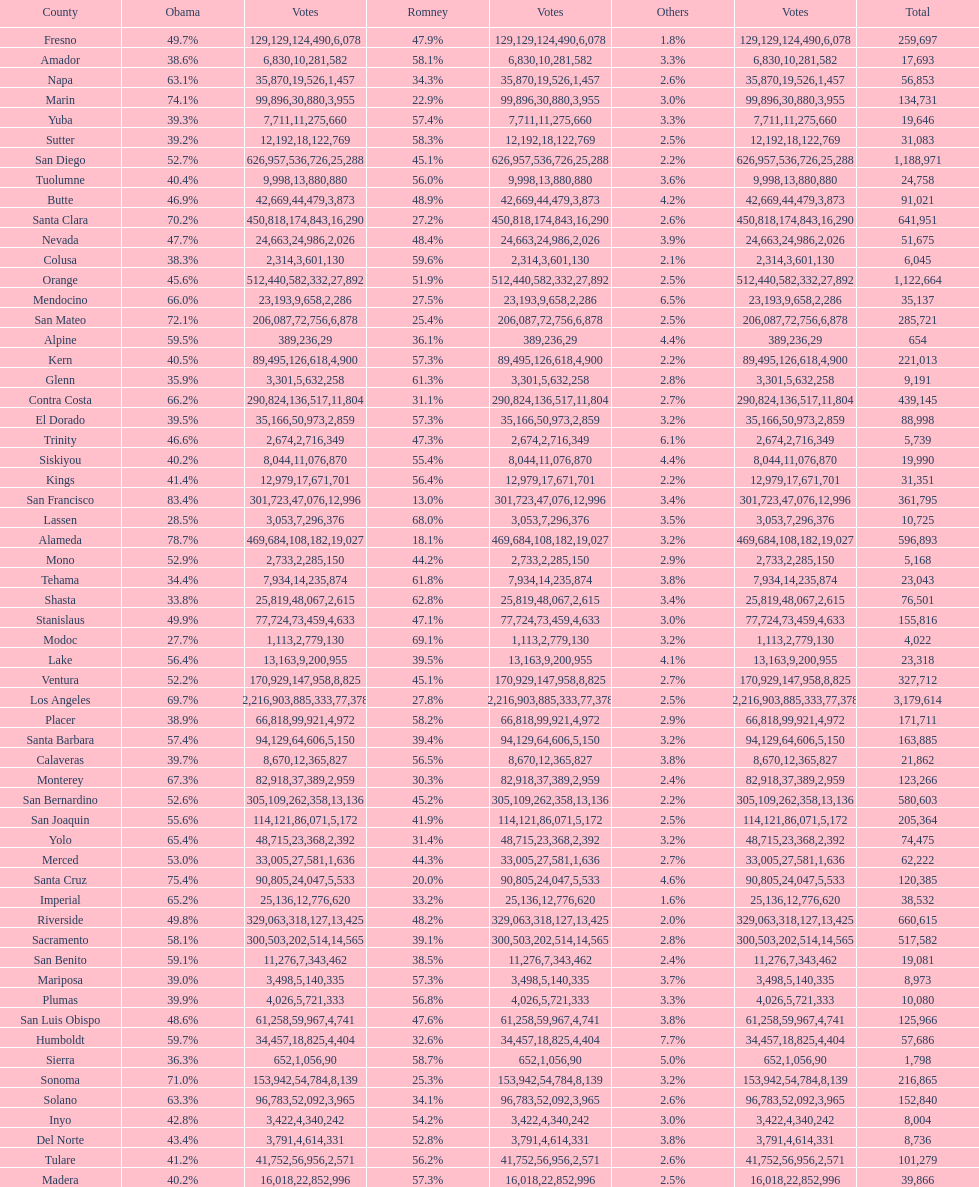Which count had the least number of votes for obama? Modoc. 